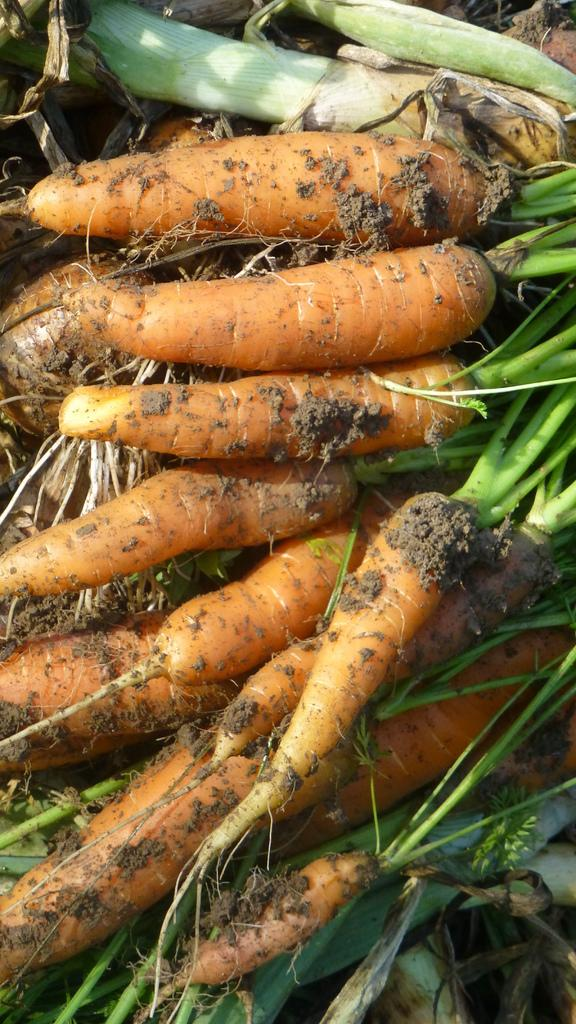What type of vegetable is present in the image? There are carrots in the image. What part of the carrots is visible in the image? The carrots have roots in the image. What else can be seen on the carrots? There are mud particles on the carrots. What type of suit is hanging on the front of the carrots in the image? There is no suit present in the image, as it features carrots with roots and mud particles. 